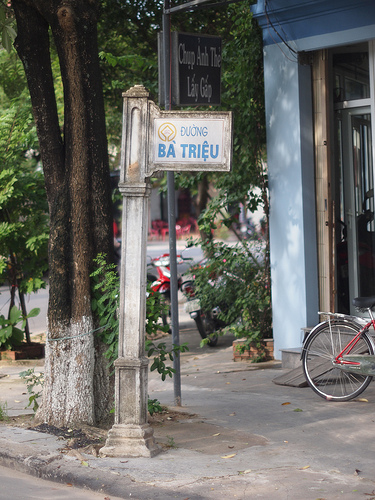Please provide a short description for this region: [0.23, 0.02, 0.35, 0.26]. The region [0.23, 0.02, 0.35, 0.26] contains a tree in the picture. 